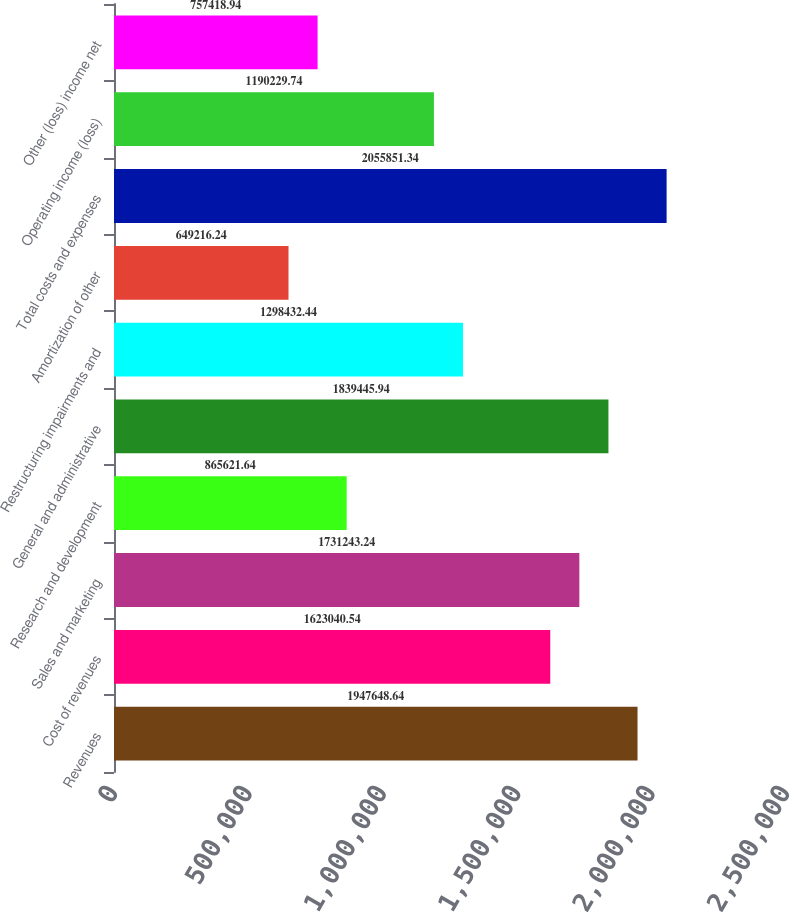Convert chart to OTSL. <chart><loc_0><loc_0><loc_500><loc_500><bar_chart><fcel>Revenues<fcel>Cost of revenues<fcel>Sales and marketing<fcel>Research and development<fcel>General and administrative<fcel>Restructuring impairments and<fcel>Amortization of other<fcel>Total costs and expenses<fcel>Operating income (loss)<fcel>Other (loss) income net<nl><fcel>1.94765e+06<fcel>1.62304e+06<fcel>1.73124e+06<fcel>865622<fcel>1.83945e+06<fcel>1.29843e+06<fcel>649216<fcel>2.05585e+06<fcel>1.19023e+06<fcel>757419<nl></chart> 